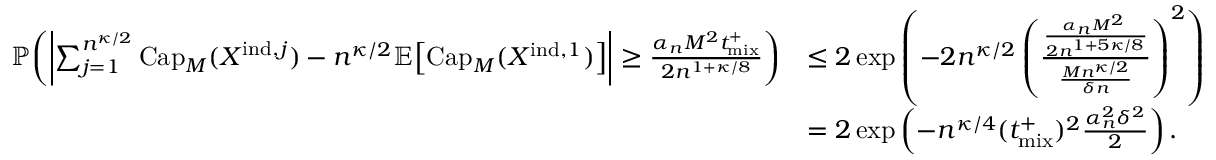Convert formula to latex. <formula><loc_0><loc_0><loc_500><loc_500>\begin{array} { r l } { \mathbb { P } \, \left ( \left | \sum _ { j = 1 } ^ { n ^ { \kappa / 2 } } C a p _ { M } ( X ^ { i n d , j } ) - n ^ { \kappa / 2 } \mathbb { E } \, \left [ C a p _ { M } ( X ^ { i n d , 1 } ) \right ] \right | \geq \frac { \alpha _ { n } M ^ { 2 } { t _ { m i x } ^ { + } } } { 2 n ^ { 1 + \kappa / 8 } } \right ) } & { \leq 2 \exp \left ( - 2 n ^ { \kappa / 2 } \left ( \frac { \frac { \alpha _ { n } M ^ { 2 } \ t p l u s } { 2 n ^ { 1 + 5 \kappa / 8 } } } { \frac { M n ^ { \kappa / 2 } } { \delta n } } \right ) ^ { 2 } \right ) } \\ & { = 2 \exp \left ( - n ^ { \kappa / 4 } ( { t _ { m i x } ^ { + } } ) ^ { 2 } \frac { \alpha _ { n } ^ { 2 } \delta ^ { 2 } } { 2 } \right ) . } \end{array}</formula> 